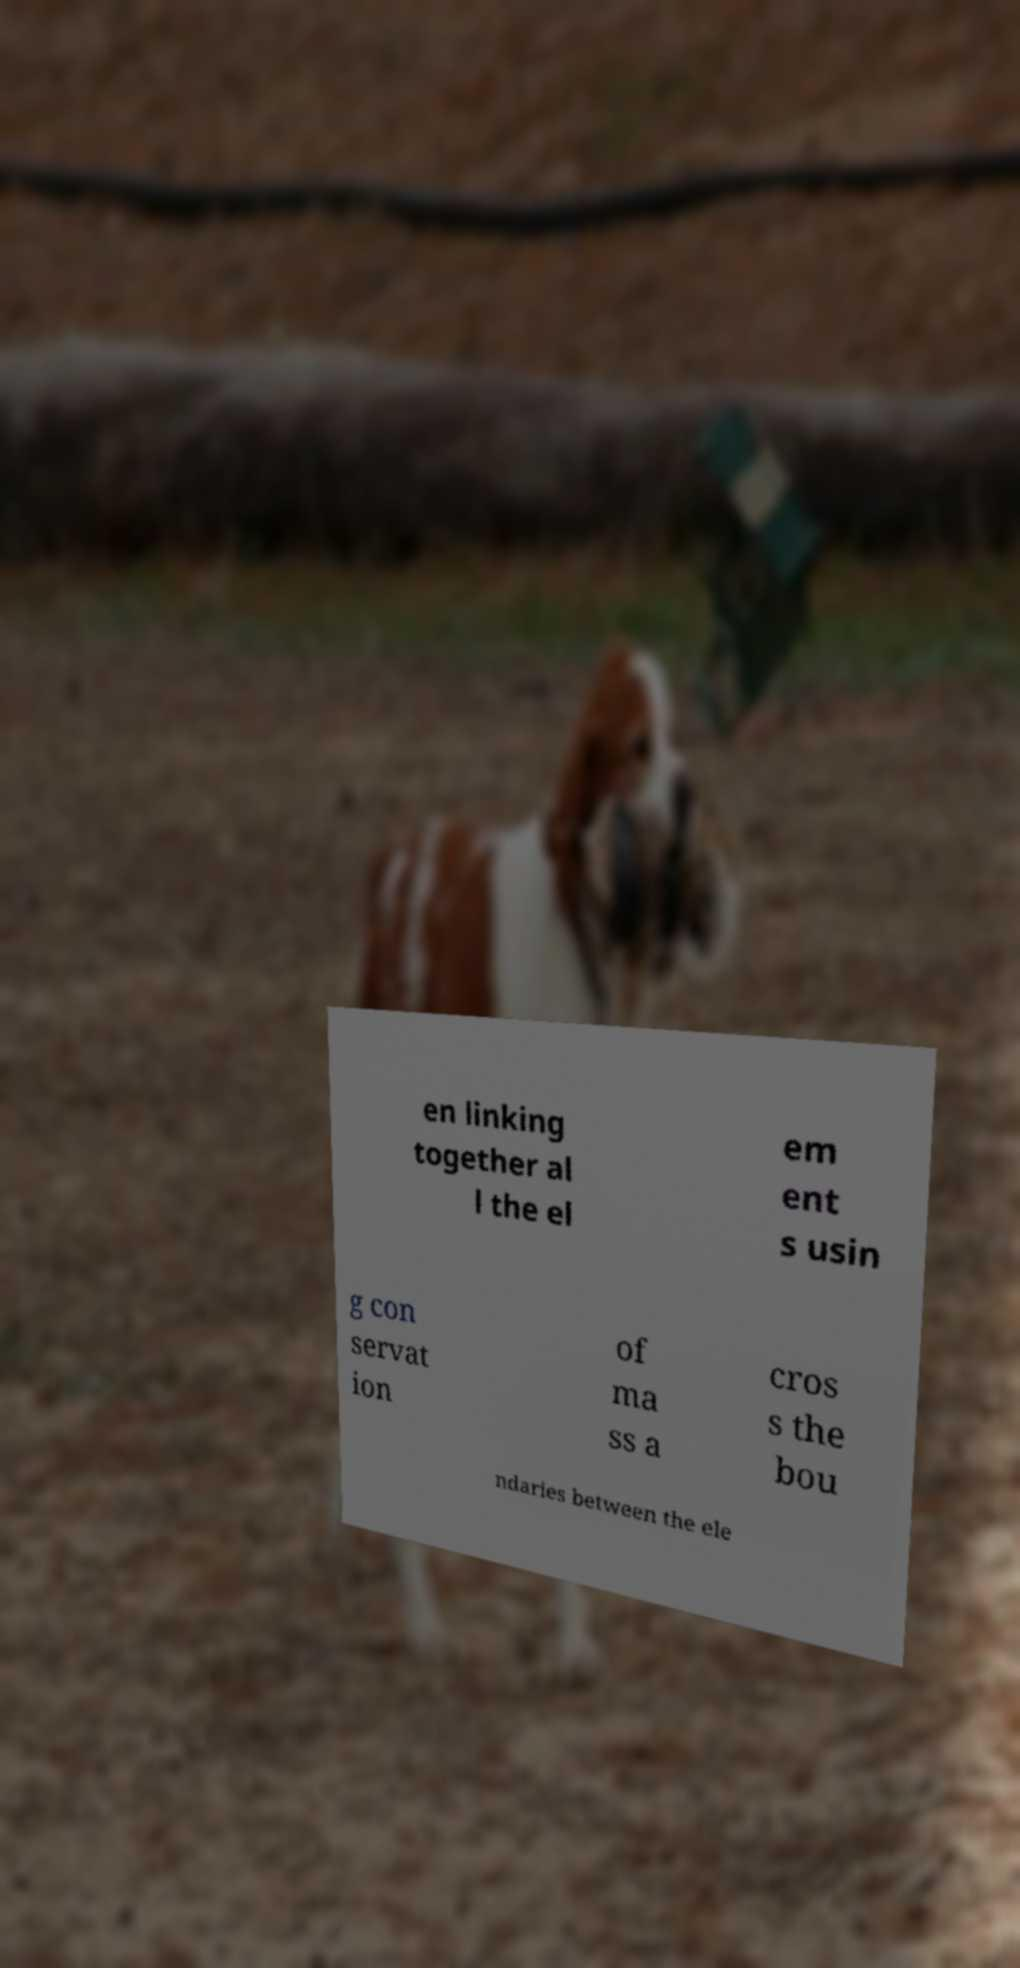For documentation purposes, I need the text within this image transcribed. Could you provide that? en linking together al l the el em ent s usin g con servat ion of ma ss a cros s the bou ndaries between the ele 